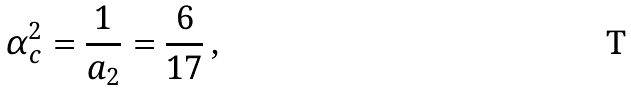Convert formula to latex. <formula><loc_0><loc_0><loc_500><loc_500>\alpha _ { c } ^ { 2 } = \frac { 1 } { a _ { 2 } } = \frac { 6 } { 1 7 } \, ,</formula> 